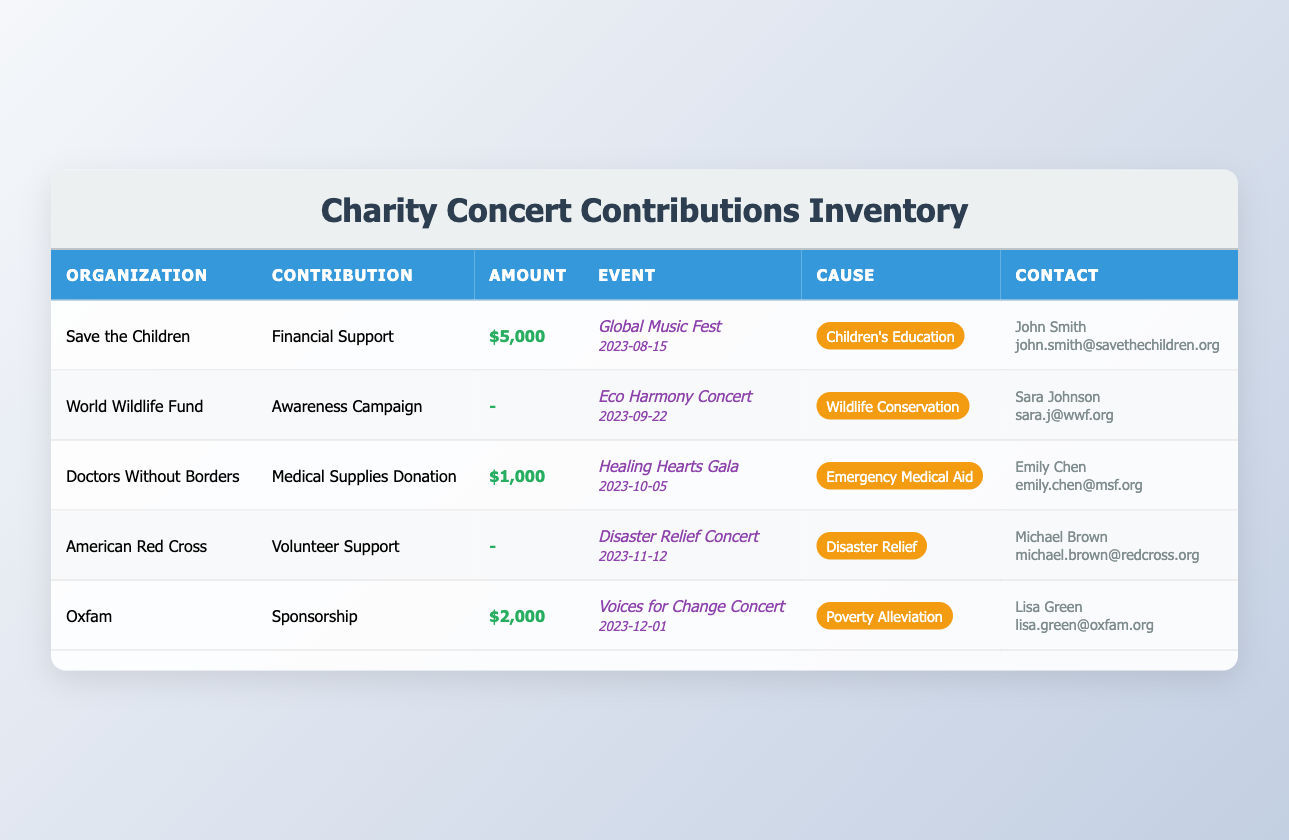What is the total financial support provided by partner organizations? The financial support amounts are given for Save the Children ($5000) and Oxfam ($2000). To find the total, we add these two values: 5000 + 2000 = 7000.
Answer: 7000 Which organization contributed to the Healing Hearts Gala? The table shows that Doctors Without Borders contributed medical supplies donation to the Healing Hearts Gala.
Answer: Doctors Without Borders Did any organizations provide volunteer support for the Disaster Relief Concert? The American Red Cross is listed as providing volunteer support, which qualifies as yes.
Answer: Yes What is the average amount contributed by organizations that made a financial contribution? The organizations making financial contributions are Save the Children ($5000), Oxfam ($2000), and Doctors Without Borders ($1000). Sum of contributions is 5000 + 2000 + 1000 = 8000. There are 3 contributions, so the average is 8000 divided by 3, which gives approximately 2666.67.
Answer: About 2666.67 Which event had the highest contribution amount? The Global Music Fest had the highest contribution of $5000 from Save the Children, which is more than the contributions for the other events.
Answer: Global Music Fest How many organizations donated medical supplies? The only organization listed as donating medical supplies is Doctors Without Borders. Therefore, the count is one.
Answer: 1 Did World Wildlife Fund make a financial contribution to their event? No, the World Wildlife Fund did not provide a financial contribution; they contributed an awareness campaign with an amount of zero.
Answer: No Which organizations contributed on or before October 5, 2023? From the table, Save the Children and Doctors Without Borders contributed before October 5. Save the Children contributed on August 15 and Doctors Without Borders on October 5. Oxfam's contribution is on December 1, which is after.
Answer: Save the Children and Doctors Without Borders What is the total number of events that occurred in 2023? Counting the events listed, there are five events in total for the year 2023—each organization has one event shown in the table.
Answer: 5 